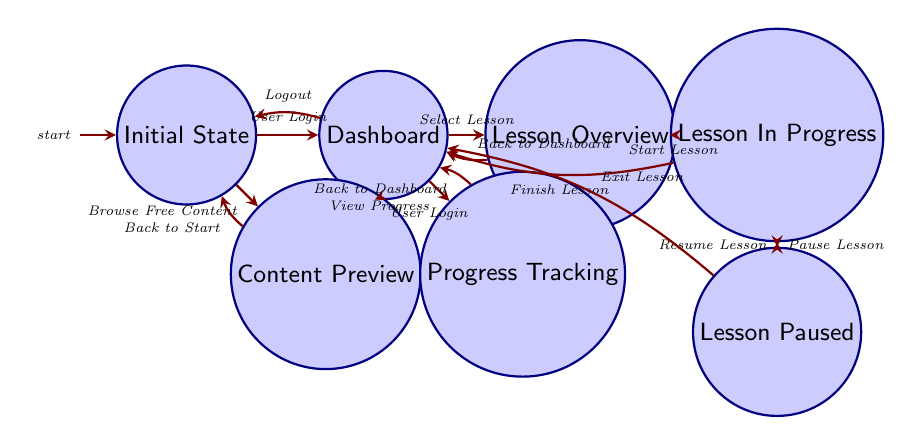What is the starting state when the user first opens the platform? The diagram indicates that the starting state when the user first opens the platform is called "Initial State."
Answer: Initial State How many transitions are there from the "Dashboard" state? By examining the "Dashboard" state, we see that there are three transitions: "Select Lesson," "View Progress," and "Logout." Thus, the total number of transitions from this state is three.
Answer: 3 Which state follows the "UserLogin" event from the "InitialState"? The transition from the "InitialState" labeled "UserLogin" leads directly to the "Dashboard" state, indicating that this is the next state after the event occurs.
Answer: Dashboard What event leads back to the "InitialState" from the "Dashboard"? The event that leads back to the "InitialState" from the "Dashboard" is the "Logout" event, as indicated by the directed transition in the diagram.
Answer: Logout What is the state transition if the user selects a lesson from the "Dashboard"? If the user selects a lesson from the "Dashboard," the transition will take them to the "Lesson Overview" state as per the flow indicated in the diagram.
Answer: Lesson Overview What is the final state after finishing a lesson while in "Lesson In Progress"? Upon finishing the lesson in the "Lesson In Progress" state, the user is directed back to the "Dashboard," representing the final state after the lesson is complete.
Answer: Dashboard How does the user return to the "Dashboard" from "Lesson Overview"? The user can return to the "Dashboard" from the "Lesson Overview" state by executing the "Back to Dashboard" event, which is illustrated as a transition in the diagram.
Answer: Back to Dashboard How many total states are present in the diagram? By counting all the distinct labeled states in the diagram, we identify a total of six states: "InitialState," "Dashboard," "ContentPreview," "LessonOverview," "LessonInProgress," and "LessonPaused."
Answer: 6 What state is reached when a lesson is paused? When the lesson is paused, the state that is reached is called "Lesson Paused," as indicated by the transition from "Lesson In Progress" to "Lesson Paused."
Answer: Lesson Paused 